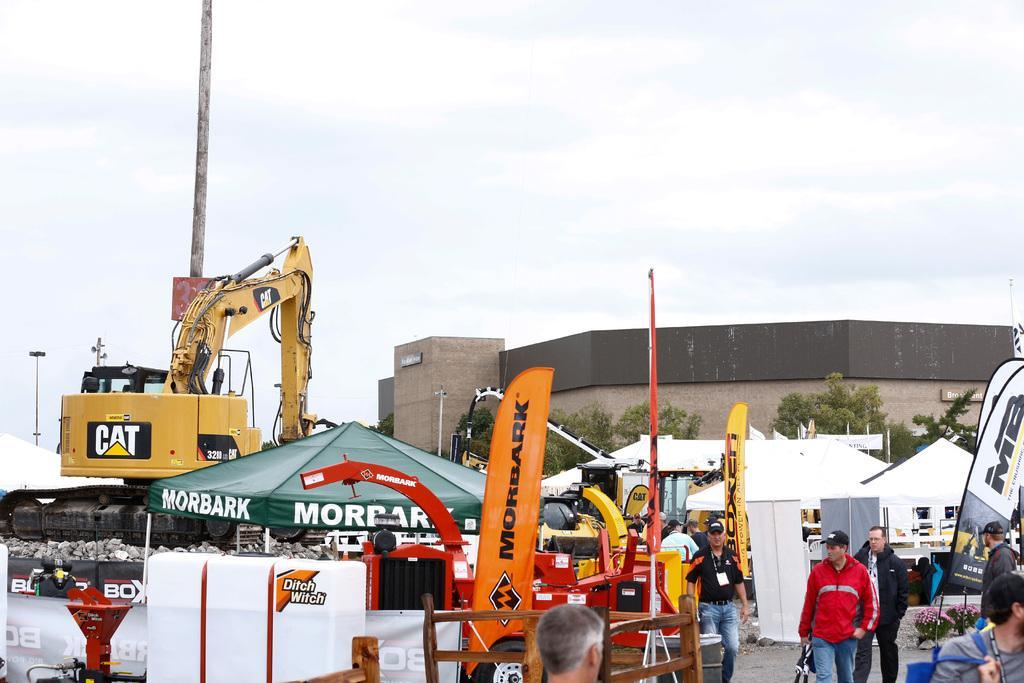Could you give a brief overview of what you see in this image? In the image in the center, we can see the tents, cranes, banners, ladders, boxes, stones, few people were standing and holding some objects and a few other objects. In the background we can see the sky, clouds, buildings, trees etc. 